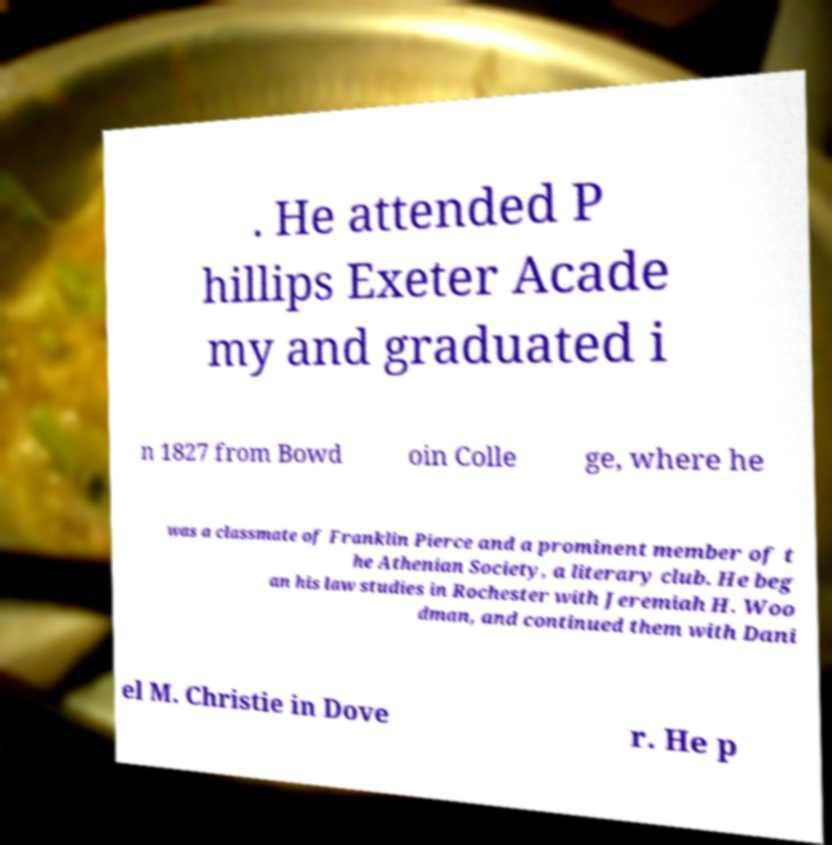Please identify and transcribe the text found in this image. . He attended P hillips Exeter Acade my and graduated i n 1827 from Bowd oin Colle ge, where he was a classmate of Franklin Pierce and a prominent member of t he Athenian Society, a literary club. He beg an his law studies in Rochester with Jeremiah H. Woo dman, and continued them with Dani el M. Christie in Dove r. He p 